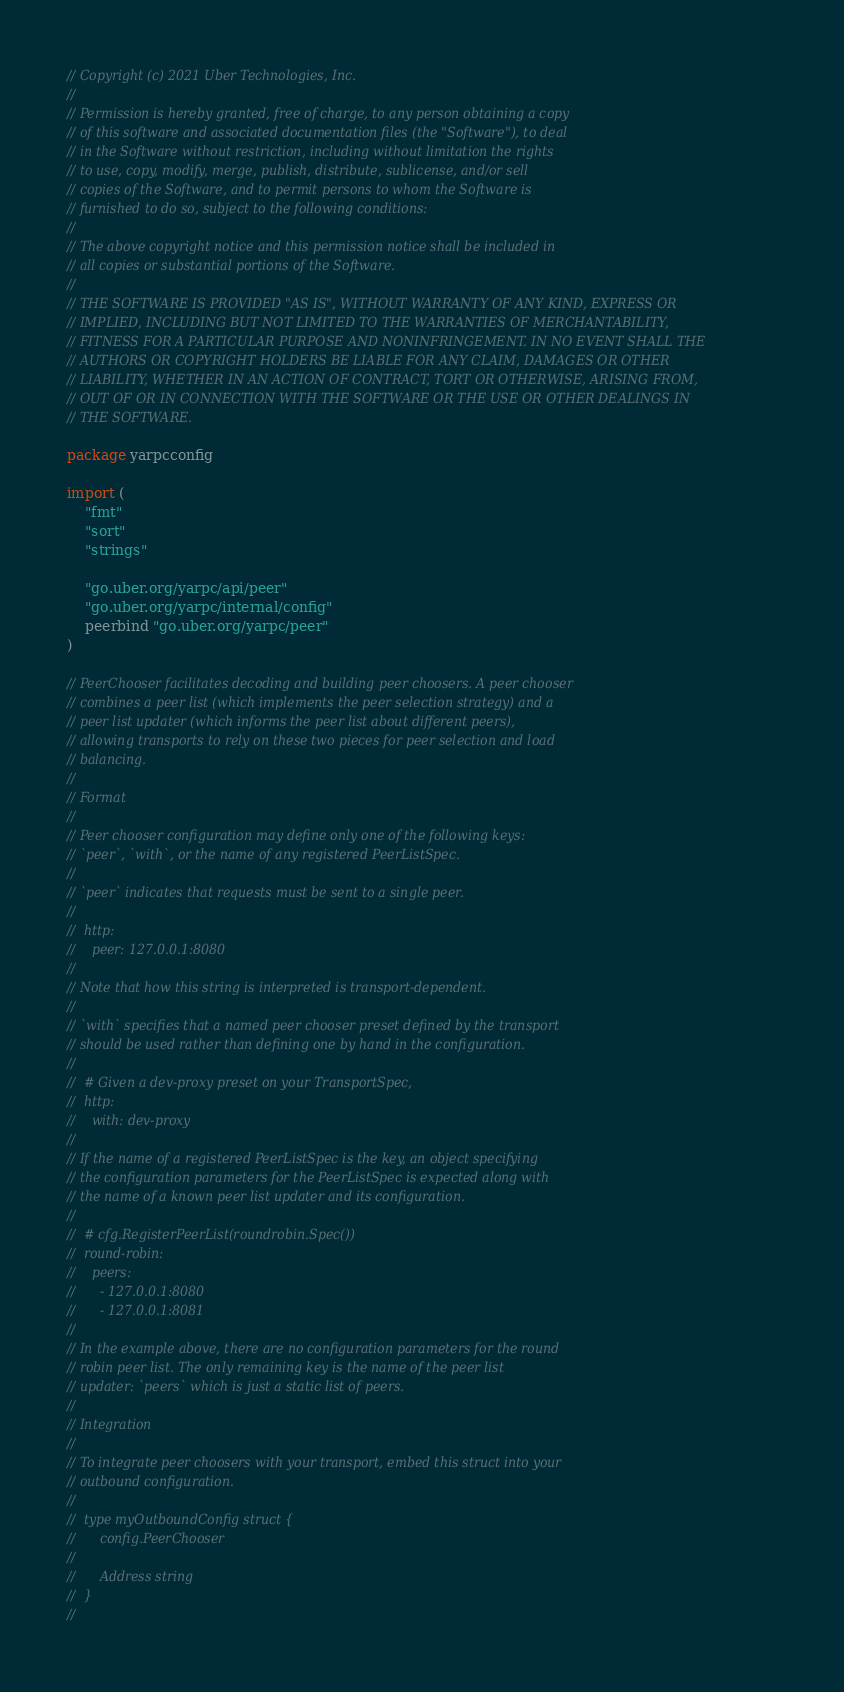<code> <loc_0><loc_0><loc_500><loc_500><_Go_>// Copyright (c) 2021 Uber Technologies, Inc.
//
// Permission is hereby granted, free of charge, to any person obtaining a copy
// of this software and associated documentation files (the "Software"), to deal
// in the Software without restriction, including without limitation the rights
// to use, copy, modify, merge, publish, distribute, sublicense, and/or sell
// copies of the Software, and to permit persons to whom the Software is
// furnished to do so, subject to the following conditions:
//
// The above copyright notice and this permission notice shall be included in
// all copies or substantial portions of the Software.
//
// THE SOFTWARE IS PROVIDED "AS IS", WITHOUT WARRANTY OF ANY KIND, EXPRESS OR
// IMPLIED, INCLUDING BUT NOT LIMITED TO THE WARRANTIES OF MERCHANTABILITY,
// FITNESS FOR A PARTICULAR PURPOSE AND NONINFRINGEMENT. IN NO EVENT SHALL THE
// AUTHORS OR COPYRIGHT HOLDERS BE LIABLE FOR ANY CLAIM, DAMAGES OR OTHER
// LIABILITY, WHETHER IN AN ACTION OF CONTRACT, TORT OR OTHERWISE, ARISING FROM,
// OUT OF OR IN CONNECTION WITH THE SOFTWARE OR THE USE OR OTHER DEALINGS IN
// THE SOFTWARE.

package yarpcconfig

import (
	"fmt"
	"sort"
	"strings"

	"go.uber.org/yarpc/api/peer"
	"go.uber.org/yarpc/internal/config"
	peerbind "go.uber.org/yarpc/peer"
)

// PeerChooser facilitates decoding and building peer choosers. A peer chooser
// combines a peer list (which implements the peer selection strategy) and a
// peer list updater (which informs the peer list about different peers),
// allowing transports to rely on these two pieces for peer selection and load
// balancing.
//
// Format
//
// Peer chooser configuration may define only one of the following keys:
// `peer`, `with`, or the name of any registered PeerListSpec.
//
// `peer` indicates that requests must be sent to a single peer.
//
// 	http:
// 	  peer: 127.0.0.1:8080
//
// Note that how this string is interpreted is transport-dependent.
//
// `with` specifies that a named peer chooser preset defined by the transport
// should be used rather than defining one by hand in the configuration.
//
// 	# Given a dev-proxy preset on your TransportSpec,
// 	http:
// 	  with: dev-proxy
//
// If the name of a registered PeerListSpec is the key, an object specifying
// the configuration parameters for the PeerListSpec is expected along with
// the name of a known peer list updater and its configuration.
//
// 	# cfg.RegisterPeerList(roundrobin.Spec())
// 	round-robin:
// 	  peers:
// 	    - 127.0.0.1:8080
// 	    - 127.0.0.1:8081
//
// In the example above, there are no configuration parameters for the round
// robin peer list. The only remaining key is the name of the peer list
// updater: `peers` which is just a static list of peers.
//
// Integration
//
// To integrate peer choosers with your transport, embed this struct into your
// outbound configuration.
//
// 	type myOutboundConfig struct {
// 		config.PeerChooser
//
// 		Address string
// 	}
//</code> 